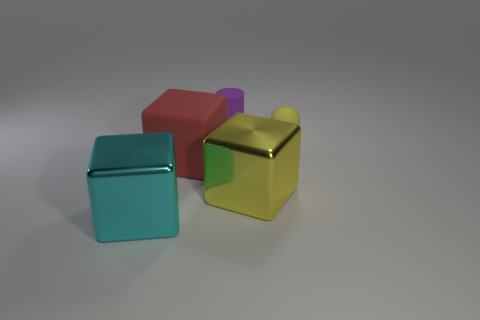Add 1 tiny red spheres. How many objects exist? 6 Subtract all spheres. How many objects are left? 4 Add 1 cyan metallic things. How many cyan metallic things are left? 2 Add 2 red rubber objects. How many red rubber objects exist? 3 Subtract 0 cyan cylinders. How many objects are left? 5 Subtract all brown matte spheres. Subtract all yellow blocks. How many objects are left? 4 